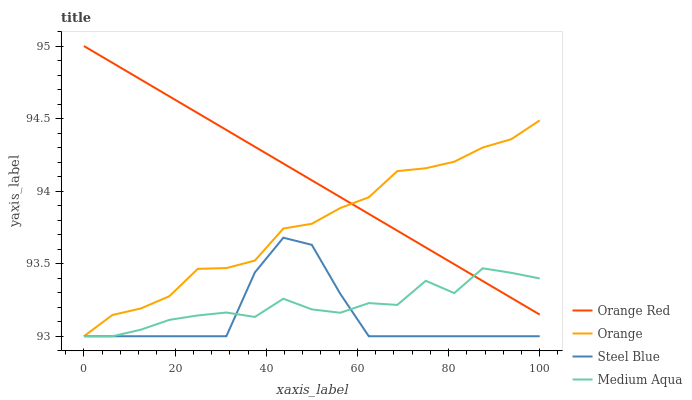Does Steel Blue have the minimum area under the curve?
Answer yes or no. Yes. Does Orange Red have the maximum area under the curve?
Answer yes or no. Yes. Does Medium Aqua have the minimum area under the curve?
Answer yes or no. No. Does Medium Aqua have the maximum area under the curve?
Answer yes or no. No. Is Orange Red the smoothest?
Answer yes or no. Yes. Is Medium Aqua the roughest?
Answer yes or no. Yes. Is Medium Aqua the smoothest?
Answer yes or no. No. Is Orange Red the roughest?
Answer yes or no. No. Does Orange have the lowest value?
Answer yes or no. Yes. Does Orange Red have the lowest value?
Answer yes or no. No. Does Orange Red have the highest value?
Answer yes or no. Yes. Does Medium Aqua have the highest value?
Answer yes or no. No. Is Steel Blue less than Orange Red?
Answer yes or no. Yes. Is Orange Red greater than Steel Blue?
Answer yes or no. Yes. Does Steel Blue intersect Medium Aqua?
Answer yes or no. Yes. Is Steel Blue less than Medium Aqua?
Answer yes or no. No. Is Steel Blue greater than Medium Aqua?
Answer yes or no. No. Does Steel Blue intersect Orange Red?
Answer yes or no. No. 